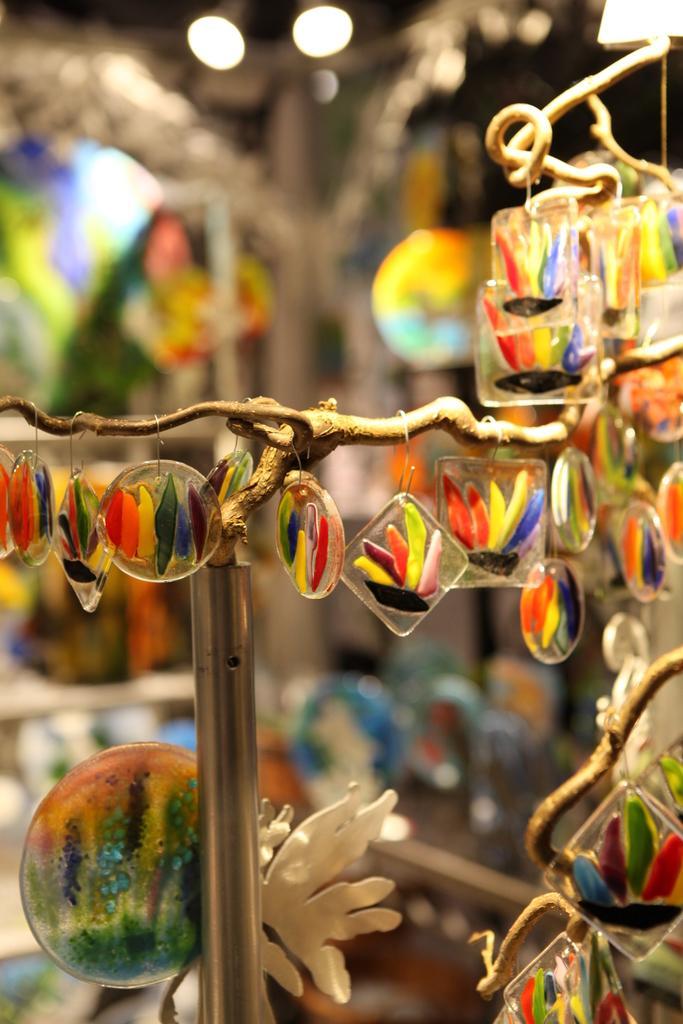Could you give a brief overview of what you see in this image? There are some decorative show pieces are present as we can see in the middle of this image. 